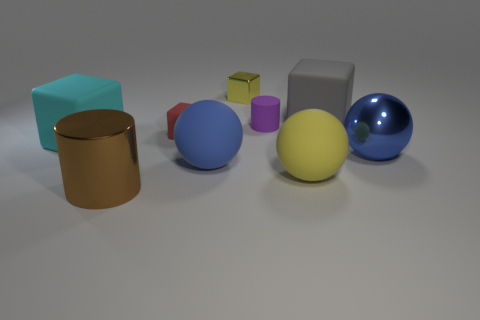Add 1 large green balls. How many objects exist? 10 Subtract all blocks. How many objects are left? 5 Subtract all yellow metallic balls. Subtract all big cyan rubber objects. How many objects are left? 8 Add 1 tiny red blocks. How many tiny red blocks are left? 2 Add 3 metallic blocks. How many metallic blocks exist? 4 Subtract 0 blue blocks. How many objects are left? 9 